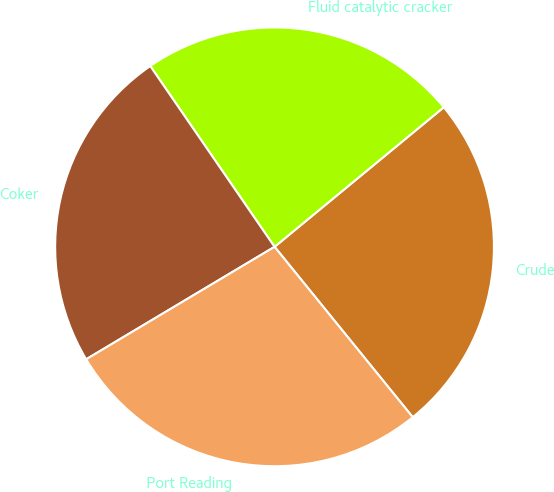<chart> <loc_0><loc_0><loc_500><loc_500><pie_chart><fcel>Crude<fcel>Fluid catalytic cracker<fcel>Coker<fcel>Port Reading<nl><fcel>25.13%<fcel>23.61%<fcel>23.98%<fcel>27.28%<nl></chart> 